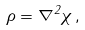<formula> <loc_0><loc_0><loc_500><loc_500>\rho = { \nabla } ^ { 2 } \chi \, ,</formula> 